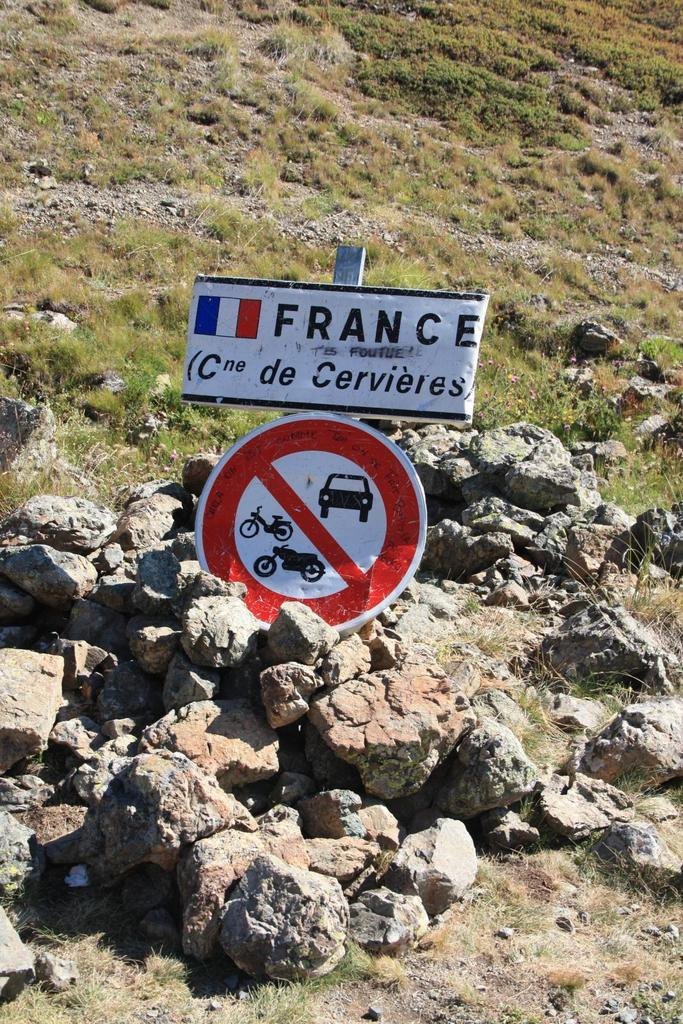<image>
Provide a brief description of the given image. A mount of dirt with a french sign saying no vehicles. 